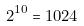<formula> <loc_0><loc_0><loc_500><loc_500>2 ^ { 1 0 } = 1 0 2 4</formula> 